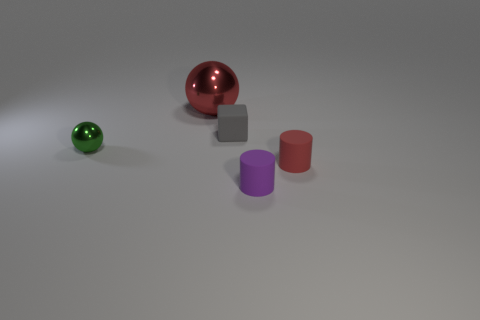Add 5 green shiny objects. How many objects exist? 10 Subtract all balls. How many objects are left? 3 Add 2 purple rubber cylinders. How many purple rubber cylinders are left? 3 Add 3 small yellow matte blocks. How many small yellow matte blocks exist? 3 Subtract 0 cyan spheres. How many objects are left? 5 Subtract all small gray rubber objects. Subtract all large red metal spheres. How many objects are left? 3 